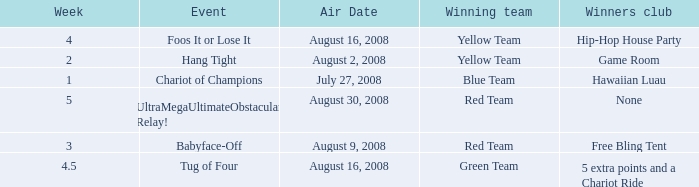How many weeks have a Winning team of yellow team, and an Event of foos it or lose it? 4.0. 